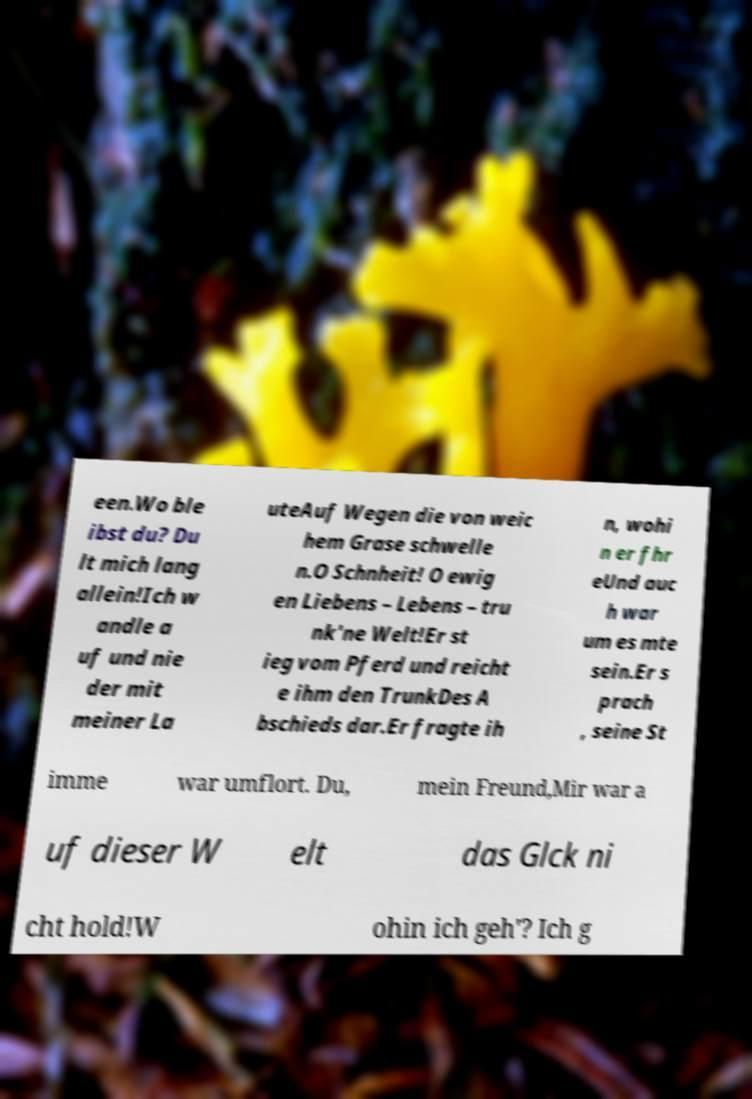Can you read and provide the text displayed in the image?This photo seems to have some interesting text. Can you extract and type it out for me? een.Wo ble ibst du? Du lt mich lang allein!Ich w andle a uf und nie der mit meiner La uteAuf Wegen die von weic hem Grase schwelle n.O Schnheit! O ewig en Liebens – Lebens – tru nk'ne Welt!Er st ieg vom Pferd und reicht e ihm den TrunkDes A bschieds dar.Er fragte ih n, wohi n er fhr eUnd auc h war um es mte sein.Er s prach , seine St imme war umflort. Du, mein Freund,Mir war a uf dieser W elt das Glck ni cht hold!W ohin ich geh'? Ich g 